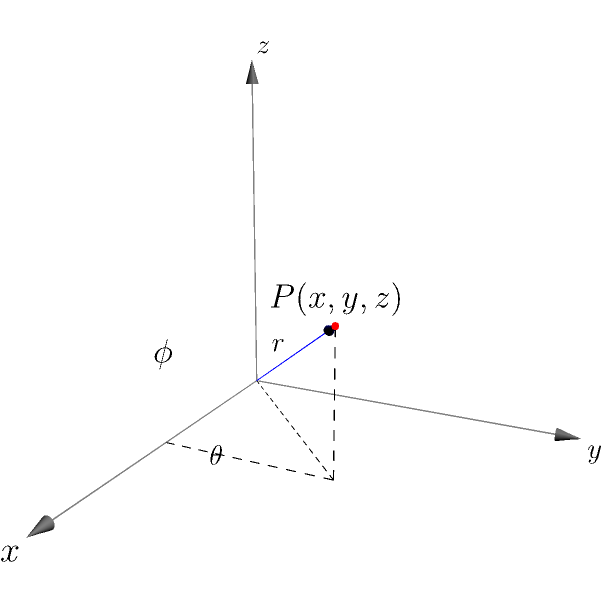A 3D-printed centrifuge component needs to be designed for a laboratory application. The component's critical point P is initially given in Cartesian coordinates (x, y, z) = (2, 2, 2√2) cm. For manufacturing purposes, these coordinates need to be converted to spherical coordinates (r, θ, φ). Calculate the spherical coordinates of point P. To convert from Cartesian coordinates (x, y, z) to spherical coordinates (r, θ, φ), we follow these steps:

1. Calculate r:
   $$r = \sqrt{x^2 + y^2 + z^2}$$
   $$r = \sqrt{2^2 + 2^2 + (2\sqrt{2})^2} = \sqrt{4 + 4 + 8} = \sqrt{16} = 4 \text{ cm}$$

2. Calculate θ (azimuthal angle):
   $$\theta = \arctan\left(\frac{y}{x}\right)$$
   $$\theta = \arctan\left(\frac{2}{2}\right) = \arctan(1) = \frac{\pi}{4} \text{ radians} = 45°$$

3. Calculate φ (polar angle):
   $$\phi = \arccos\left(\frac{z}{r}\right)$$
   $$\phi = \arccos\left(\frac{2\sqrt{2}}{4}\right) = \arccos\left(\frac{\sqrt{2}}{2}\right) = \frac{\pi}{4} \text{ radians} = 45°$$

Therefore, the spherical coordinates of point P are (r, θ, φ) = (4 cm, π/4 rad, π/4 rad) or (4 cm, 45°, 45°).
Answer: (4 cm, π/4 rad, π/4 rad) 